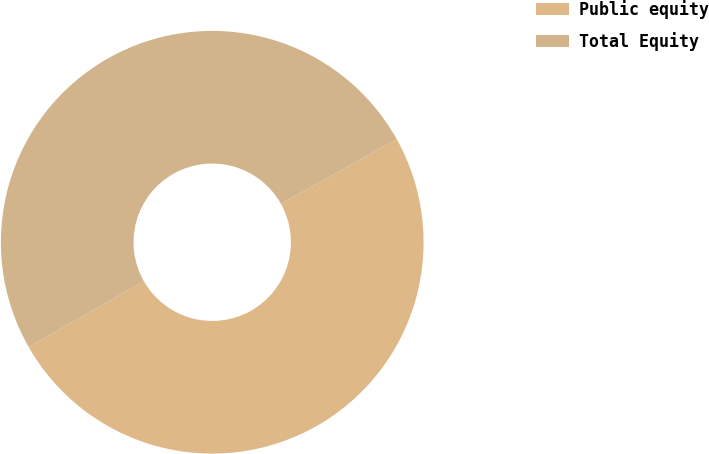Convert chart. <chart><loc_0><loc_0><loc_500><loc_500><pie_chart><fcel>Public equity<fcel>Total Equity<nl><fcel>49.85%<fcel>50.15%<nl></chart> 